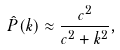<formula> <loc_0><loc_0><loc_500><loc_500>\hat { P } ( k ) \approx \frac { c ^ { 2 } } { c ^ { 2 } + k ^ { 2 } } ,</formula> 